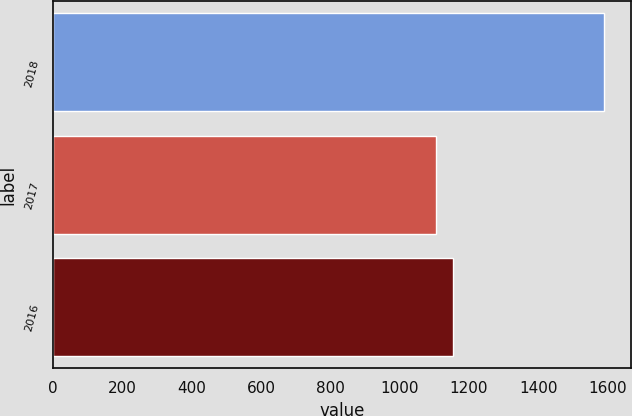<chart> <loc_0><loc_0><loc_500><loc_500><bar_chart><fcel>2018<fcel>2017<fcel>2016<nl><fcel>1589<fcel>1105<fcel>1153.4<nl></chart> 